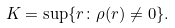<formula> <loc_0><loc_0><loc_500><loc_500>K = \sup \{ r \colon \rho ( r ) \neq 0 \} .</formula> 